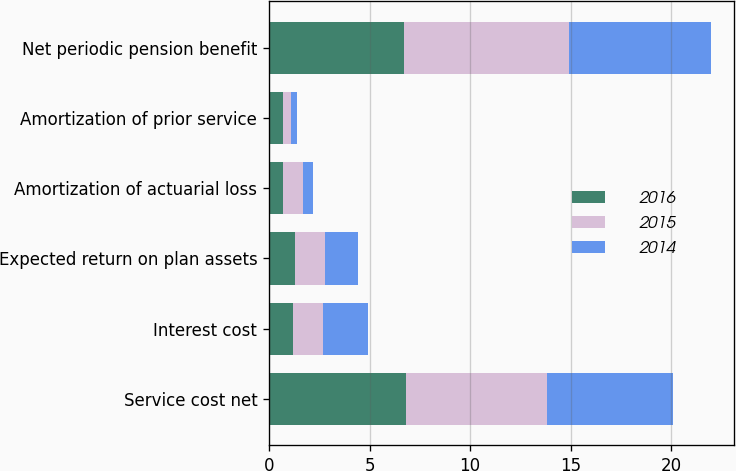Convert chart. <chart><loc_0><loc_0><loc_500><loc_500><stacked_bar_chart><ecel><fcel>Service cost net<fcel>Interest cost<fcel>Expected return on plan assets<fcel>Amortization of actuarial loss<fcel>Amortization of prior service<fcel>Net periodic pension benefit<nl><fcel>2016<fcel>6.8<fcel>1.2<fcel>1.3<fcel>0.7<fcel>0.7<fcel>6.7<nl><fcel>2015<fcel>7<fcel>1.5<fcel>1.5<fcel>1<fcel>0.4<fcel>8.2<nl><fcel>2014<fcel>6.3<fcel>2.2<fcel>1.6<fcel>0.5<fcel>0.3<fcel>7.1<nl></chart> 